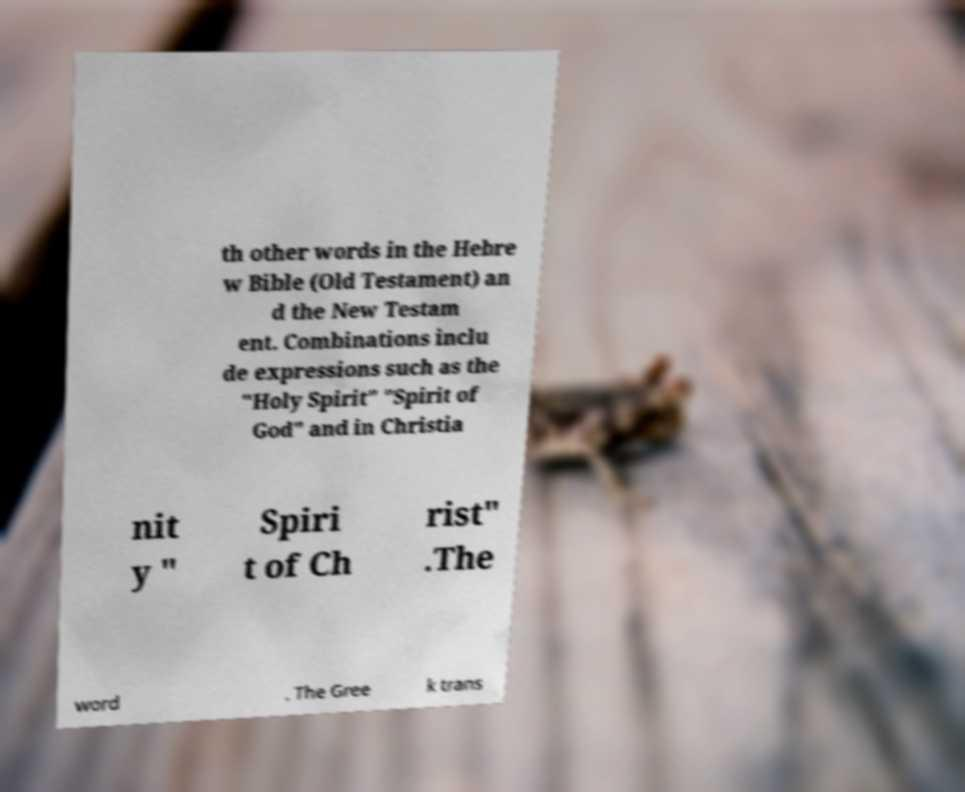For documentation purposes, I need the text within this image transcribed. Could you provide that? th other words in the Hebre w Bible (Old Testament) an d the New Testam ent. Combinations inclu de expressions such as the "Holy Spirit" "Spirit of God" and in Christia nit y " Spiri t of Ch rist" .The word . The Gree k trans 